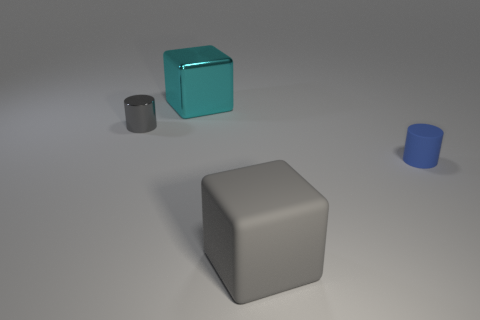Are there more big cyan metallic cubes than big things?
Offer a very short reply. No. There is a gray object in front of the tiny cylinder left of the tiny matte cylinder; is there a big object that is right of it?
Your answer should be compact. No. What number of other objects are there of the same size as the gray shiny object?
Keep it short and to the point. 1. There is a big metallic cube; are there any tiny blue objects left of it?
Offer a very short reply. No. Does the large shiny thing have the same color as the shiny object that is to the left of the big cyan shiny block?
Offer a terse response. No. There is a small cylinder on the left side of the tiny object to the right of the gray object that is to the left of the cyan cube; what is its color?
Provide a succinct answer. Gray. Is there a yellow shiny object of the same shape as the large rubber object?
Make the answer very short. No. The shiny cylinder that is the same size as the blue matte object is what color?
Give a very brief answer. Gray. There is a object left of the large metal thing; what is its material?
Ensure brevity in your answer.  Metal. There is a shiny object that is on the left side of the cyan object; does it have the same shape as the big thing that is in front of the metal block?
Provide a short and direct response. No. 